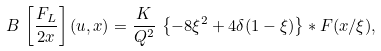<formula> <loc_0><loc_0><loc_500><loc_500>B \, \left [ \frac { F _ { L } } { 2 x } \right ] ( u , x ) = \frac { K } { Q ^ { 2 } } \, \left \{ - 8 \xi ^ { 2 } + 4 \delta ( 1 - \xi ) \right \} * F ( x / \xi ) ,</formula> 